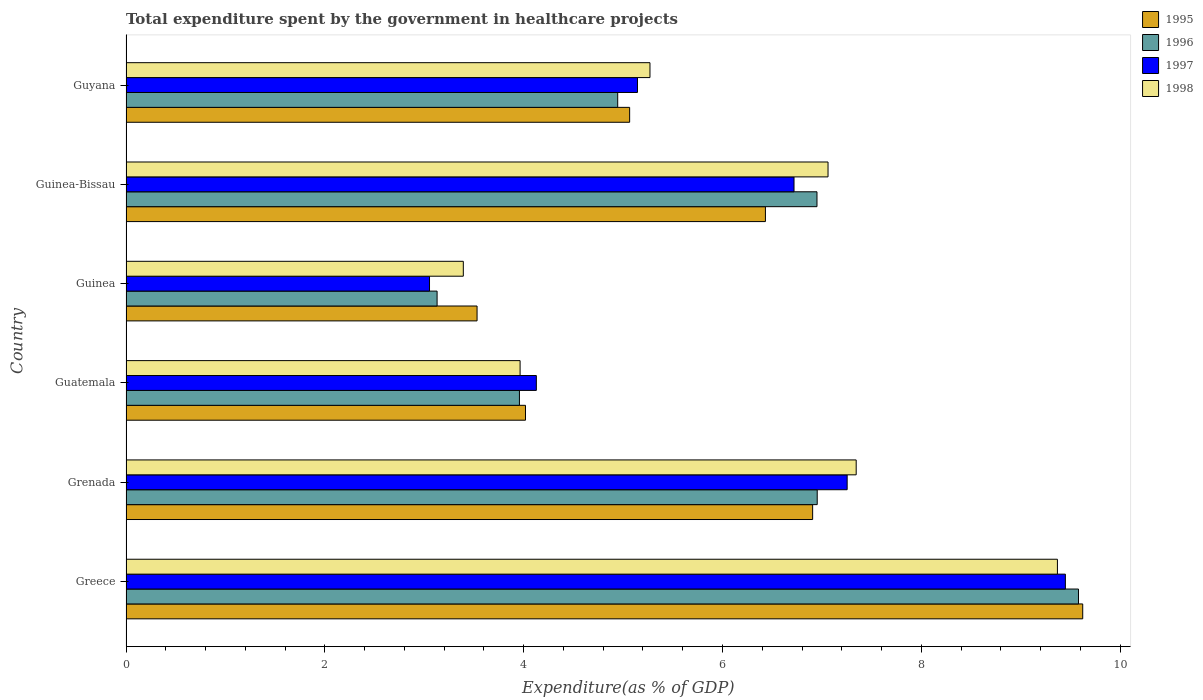How many different coloured bars are there?
Your response must be concise. 4. Are the number of bars on each tick of the Y-axis equal?
Your answer should be very brief. Yes. How many bars are there on the 6th tick from the top?
Give a very brief answer. 4. What is the label of the 3rd group of bars from the top?
Your answer should be very brief. Guinea. What is the total expenditure spent by the government in healthcare projects in 1998 in Grenada?
Your answer should be compact. 7.35. Across all countries, what is the maximum total expenditure spent by the government in healthcare projects in 1997?
Provide a succinct answer. 9.45. Across all countries, what is the minimum total expenditure spent by the government in healthcare projects in 1995?
Offer a terse response. 3.53. In which country was the total expenditure spent by the government in healthcare projects in 1995 maximum?
Provide a short and direct response. Greece. In which country was the total expenditure spent by the government in healthcare projects in 1996 minimum?
Keep it short and to the point. Guinea. What is the total total expenditure spent by the government in healthcare projects in 1998 in the graph?
Your response must be concise. 36.4. What is the difference between the total expenditure spent by the government in healthcare projects in 1995 in Guatemala and that in Guinea-Bissau?
Your answer should be compact. -2.41. What is the difference between the total expenditure spent by the government in healthcare projects in 1995 in Guyana and the total expenditure spent by the government in healthcare projects in 1998 in Grenada?
Provide a short and direct response. -2.28. What is the average total expenditure spent by the government in healthcare projects in 1998 per country?
Provide a succinct answer. 6.07. What is the difference between the total expenditure spent by the government in healthcare projects in 1998 and total expenditure spent by the government in healthcare projects in 1997 in Guatemala?
Keep it short and to the point. -0.16. What is the ratio of the total expenditure spent by the government in healthcare projects in 1996 in Grenada to that in Guinea?
Offer a very short reply. 2.22. Is the difference between the total expenditure spent by the government in healthcare projects in 1998 in Guinea-Bissau and Guyana greater than the difference between the total expenditure spent by the government in healthcare projects in 1997 in Guinea-Bissau and Guyana?
Provide a succinct answer. Yes. What is the difference between the highest and the second highest total expenditure spent by the government in healthcare projects in 1995?
Provide a short and direct response. 2.72. What is the difference between the highest and the lowest total expenditure spent by the government in healthcare projects in 1996?
Your answer should be very brief. 6.45. Is the sum of the total expenditure spent by the government in healthcare projects in 1997 in Greece and Guatemala greater than the maximum total expenditure spent by the government in healthcare projects in 1995 across all countries?
Provide a succinct answer. Yes. Is it the case that in every country, the sum of the total expenditure spent by the government in healthcare projects in 1996 and total expenditure spent by the government in healthcare projects in 1997 is greater than the sum of total expenditure spent by the government in healthcare projects in 1995 and total expenditure spent by the government in healthcare projects in 1998?
Keep it short and to the point. No. What does the 4th bar from the bottom in Guinea-Bissau represents?
Give a very brief answer. 1998. Is it the case that in every country, the sum of the total expenditure spent by the government in healthcare projects in 1996 and total expenditure spent by the government in healthcare projects in 1998 is greater than the total expenditure spent by the government in healthcare projects in 1997?
Make the answer very short. Yes. How many bars are there?
Your answer should be very brief. 24. What is the difference between two consecutive major ticks on the X-axis?
Make the answer very short. 2. Does the graph contain any zero values?
Keep it short and to the point. No. Does the graph contain grids?
Ensure brevity in your answer.  No. Where does the legend appear in the graph?
Offer a very short reply. Top right. What is the title of the graph?
Give a very brief answer. Total expenditure spent by the government in healthcare projects. What is the label or title of the X-axis?
Make the answer very short. Expenditure(as % of GDP). What is the label or title of the Y-axis?
Ensure brevity in your answer.  Country. What is the Expenditure(as % of GDP) in 1995 in Greece?
Your response must be concise. 9.62. What is the Expenditure(as % of GDP) in 1996 in Greece?
Your answer should be very brief. 9.58. What is the Expenditure(as % of GDP) in 1997 in Greece?
Give a very brief answer. 9.45. What is the Expenditure(as % of GDP) of 1998 in Greece?
Ensure brevity in your answer.  9.37. What is the Expenditure(as % of GDP) in 1995 in Grenada?
Your answer should be very brief. 6.91. What is the Expenditure(as % of GDP) in 1996 in Grenada?
Provide a succinct answer. 6.95. What is the Expenditure(as % of GDP) in 1997 in Grenada?
Your answer should be very brief. 7.25. What is the Expenditure(as % of GDP) of 1998 in Grenada?
Your answer should be very brief. 7.35. What is the Expenditure(as % of GDP) of 1995 in Guatemala?
Provide a succinct answer. 4.02. What is the Expenditure(as % of GDP) of 1996 in Guatemala?
Keep it short and to the point. 3.96. What is the Expenditure(as % of GDP) of 1997 in Guatemala?
Keep it short and to the point. 4.13. What is the Expenditure(as % of GDP) of 1998 in Guatemala?
Ensure brevity in your answer.  3.96. What is the Expenditure(as % of GDP) in 1995 in Guinea?
Your response must be concise. 3.53. What is the Expenditure(as % of GDP) of 1996 in Guinea?
Your response must be concise. 3.13. What is the Expenditure(as % of GDP) of 1997 in Guinea?
Keep it short and to the point. 3.05. What is the Expenditure(as % of GDP) in 1998 in Guinea?
Make the answer very short. 3.39. What is the Expenditure(as % of GDP) of 1995 in Guinea-Bissau?
Your answer should be compact. 6.43. What is the Expenditure(as % of GDP) of 1996 in Guinea-Bissau?
Ensure brevity in your answer.  6.95. What is the Expenditure(as % of GDP) in 1997 in Guinea-Bissau?
Provide a short and direct response. 6.72. What is the Expenditure(as % of GDP) in 1998 in Guinea-Bissau?
Offer a very short reply. 7.06. What is the Expenditure(as % of GDP) of 1995 in Guyana?
Your response must be concise. 5.07. What is the Expenditure(as % of GDP) in 1996 in Guyana?
Provide a short and direct response. 4.95. What is the Expenditure(as % of GDP) of 1997 in Guyana?
Offer a very short reply. 5.15. What is the Expenditure(as % of GDP) of 1998 in Guyana?
Make the answer very short. 5.27. Across all countries, what is the maximum Expenditure(as % of GDP) in 1995?
Give a very brief answer. 9.62. Across all countries, what is the maximum Expenditure(as % of GDP) in 1996?
Make the answer very short. 9.58. Across all countries, what is the maximum Expenditure(as % of GDP) of 1997?
Provide a short and direct response. 9.45. Across all countries, what is the maximum Expenditure(as % of GDP) of 1998?
Ensure brevity in your answer.  9.37. Across all countries, what is the minimum Expenditure(as % of GDP) of 1995?
Offer a terse response. 3.53. Across all countries, what is the minimum Expenditure(as % of GDP) of 1996?
Your response must be concise. 3.13. Across all countries, what is the minimum Expenditure(as % of GDP) in 1997?
Offer a very short reply. 3.05. Across all countries, what is the minimum Expenditure(as % of GDP) of 1998?
Your answer should be very brief. 3.39. What is the total Expenditure(as % of GDP) of 1995 in the graph?
Your answer should be compact. 35.58. What is the total Expenditure(as % of GDP) of 1996 in the graph?
Your response must be concise. 35.52. What is the total Expenditure(as % of GDP) of 1997 in the graph?
Keep it short and to the point. 35.75. What is the total Expenditure(as % of GDP) of 1998 in the graph?
Ensure brevity in your answer.  36.4. What is the difference between the Expenditure(as % of GDP) of 1995 in Greece and that in Grenada?
Your answer should be very brief. 2.72. What is the difference between the Expenditure(as % of GDP) in 1996 in Greece and that in Grenada?
Make the answer very short. 2.63. What is the difference between the Expenditure(as % of GDP) of 1997 in Greece and that in Grenada?
Ensure brevity in your answer.  2.2. What is the difference between the Expenditure(as % of GDP) in 1998 in Greece and that in Grenada?
Offer a very short reply. 2.02. What is the difference between the Expenditure(as % of GDP) in 1995 in Greece and that in Guatemala?
Your answer should be very brief. 5.61. What is the difference between the Expenditure(as % of GDP) in 1996 in Greece and that in Guatemala?
Your answer should be compact. 5.62. What is the difference between the Expenditure(as % of GDP) of 1997 in Greece and that in Guatemala?
Make the answer very short. 5.32. What is the difference between the Expenditure(as % of GDP) in 1998 in Greece and that in Guatemala?
Your answer should be very brief. 5.41. What is the difference between the Expenditure(as % of GDP) of 1995 in Greece and that in Guinea?
Provide a succinct answer. 6.09. What is the difference between the Expenditure(as % of GDP) in 1996 in Greece and that in Guinea?
Offer a terse response. 6.45. What is the difference between the Expenditure(as % of GDP) in 1997 in Greece and that in Guinea?
Provide a succinct answer. 6.4. What is the difference between the Expenditure(as % of GDP) in 1998 in Greece and that in Guinea?
Give a very brief answer. 5.98. What is the difference between the Expenditure(as % of GDP) of 1995 in Greece and that in Guinea-Bissau?
Provide a succinct answer. 3.19. What is the difference between the Expenditure(as % of GDP) in 1996 in Greece and that in Guinea-Bissau?
Your answer should be very brief. 2.63. What is the difference between the Expenditure(as % of GDP) in 1997 in Greece and that in Guinea-Bissau?
Provide a short and direct response. 2.73. What is the difference between the Expenditure(as % of GDP) of 1998 in Greece and that in Guinea-Bissau?
Your answer should be very brief. 2.31. What is the difference between the Expenditure(as % of GDP) in 1995 in Greece and that in Guyana?
Give a very brief answer. 4.56. What is the difference between the Expenditure(as % of GDP) of 1996 in Greece and that in Guyana?
Give a very brief answer. 4.64. What is the difference between the Expenditure(as % of GDP) of 1997 in Greece and that in Guyana?
Ensure brevity in your answer.  4.3. What is the difference between the Expenditure(as % of GDP) in 1998 in Greece and that in Guyana?
Provide a short and direct response. 4.1. What is the difference between the Expenditure(as % of GDP) of 1995 in Grenada and that in Guatemala?
Give a very brief answer. 2.89. What is the difference between the Expenditure(as % of GDP) of 1996 in Grenada and that in Guatemala?
Your answer should be very brief. 3. What is the difference between the Expenditure(as % of GDP) in 1997 in Grenada and that in Guatemala?
Make the answer very short. 3.13. What is the difference between the Expenditure(as % of GDP) of 1998 in Grenada and that in Guatemala?
Provide a succinct answer. 3.38. What is the difference between the Expenditure(as % of GDP) of 1995 in Grenada and that in Guinea?
Your answer should be very brief. 3.38. What is the difference between the Expenditure(as % of GDP) of 1996 in Grenada and that in Guinea?
Offer a very short reply. 3.82. What is the difference between the Expenditure(as % of GDP) in 1997 in Grenada and that in Guinea?
Your response must be concise. 4.2. What is the difference between the Expenditure(as % of GDP) in 1998 in Grenada and that in Guinea?
Provide a short and direct response. 3.95. What is the difference between the Expenditure(as % of GDP) in 1995 in Grenada and that in Guinea-Bissau?
Your response must be concise. 0.47. What is the difference between the Expenditure(as % of GDP) in 1996 in Grenada and that in Guinea-Bissau?
Offer a very short reply. 0. What is the difference between the Expenditure(as % of GDP) of 1997 in Grenada and that in Guinea-Bissau?
Your response must be concise. 0.53. What is the difference between the Expenditure(as % of GDP) in 1998 in Grenada and that in Guinea-Bissau?
Keep it short and to the point. 0.28. What is the difference between the Expenditure(as % of GDP) in 1995 in Grenada and that in Guyana?
Offer a terse response. 1.84. What is the difference between the Expenditure(as % of GDP) in 1996 in Grenada and that in Guyana?
Provide a succinct answer. 2.01. What is the difference between the Expenditure(as % of GDP) of 1997 in Grenada and that in Guyana?
Provide a short and direct response. 2.11. What is the difference between the Expenditure(as % of GDP) of 1998 in Grenada and that in Guyana?
Your answer should be compact. 2.07. What is the difference between the Expenditure(as % of GDP) in 1995 in Guatemala and that in Guinea?
Provide a succinct answer. 0.49. What is the difference between the Expenditure(as % of GDP) in 1996 in Guatemala and that in Guinea?
Offer a terse response. 0.83. What is the difference between the Expenditure(as % of GDP) of 1997 in Guatemala and that in Guinea?
Provide a short and direct response. 1.07. What is the difference between the Expenditure(as % of GDP) in 1998 in Guatemala and that in Guinea?
Provide a short and direct response. 0.57. What is the difference between the Expenditure(as % of GDP) of 1995 in Guatemala and that in Guinea-Bissau?
Your response must be concise. -2.41. What is the difference between the Expenditure(as % of GDP) of 1996 in Guatemala and that in Guinea-Bissau?
Provide a succinct answer. -2.99. What is the difference between the Expenditure(as % of GDP) of 1997 in Guatemala and that in Guinea-Bissau?
Make the answer very short. -2.59. What is the difference between the Expenditure(as % of GDP) in 1998 in Guatemala and that in Guinea-Bissau?
Provide a short and direct response. -3.1. What is the difference between the Expenditure(as % of GDP) in 1995 in Guatemala and that in Guyana?
Your answer should be very brief. -1.05. What is the difference between the Expenditure(as % of GDP) of 1996 in Guatemala and that in Guyana?
Offer a terse response. -0.99. What is the difference between the Expenditure(as % of GDP) in 1997 in Guatemala and that in Guyana?
Give a very brief answer. -1.02. What is the difference between the Expenditure(as % of GDP) of 1998 in Guatemala and that in Guyana?
Provide a short and direct response. -1.31. What is the difference between the Expenditure(as % of GDP) in 1995 in Guinea and that in Guinea-Bissau?
Your answer should be very brief. -2.9. What is the difference between the Expenditure(as % of GDP) of 1996 in Guinea and that in Guinea-Bissau?
Keep it short and to the point. -3.82. What is the difference between the Expenditure(as % of GDP) of 1997 in Guinea and that in Guinea-Bissau?
Your answer should be compact. -3.67. What is the difference between the Expenditure(as % of GDP) in 1998 in Guinea and that in Guinea-Bissau?
Keep it short and to the point. -3.67. What is the difference between the Expenditure(as % of GDP) in 1995 in Guinea and that in Guyana?
Provide a succinct answer. -1.53. What is the difference between the Expenditure(as % of GDP) in 1996 in Guinea and that in Guyana?
Your response must be concise. -1.82. What is the difference between the Expenditure(as % of GDP) of 1997 in Guinea and that in Guyana?
Offer a terse response. -2.09. What is the difference between the Expenditure(as % of GDP) of 1998 in Guinea and that in Guyana?
Make the answer very short. -1.88. What is the difference between the Expenditure(as % of GDP) of 1995 in Guinea-Bissau and that in Guyana?
Provide a short and direct response. 1.37. What is the difference between the Expenditure(as % of GDP) of 1996 in Guinea-Bissau and that in Guyana?
Offer a very short reply. 2. What is the difference between the Expenditure(as % of GDP) in 1997 in Guinea-Bissau and that in Guyana?
Give a very brief answer. 1.57. What is the difference between the Expenditure(as % of GDP) of 1998 in Guinea-Bissau and that in Guyana?
Your answer should be compact. 1.79. What is the difference between the Expenditure(as % of GDP) in 1995 in Greece and the Expenditure(as % of GDP) in 1996 in Grenada?
Your response must be concise. 2.67. What is the difference between the Expenditure(as % of GDP) of 1995 in Greece and the Expenditure(as % of GDP) of 1997 in Grenada?
Make the answer very short. 2.37. What is the difference between the Expenditure(as % of GDP) of 1995 in Greece and the Expenditure(as % of GDP) of 1998 in Grenada?
Your answer should be very brief. 2.28. What is the difference between the Expenditure(as % of GDP) of 1996 in Greece and the Expenditure(as % of GDP) of 1997 in Grenada?
Ensure brevity in your answer.  2.33. What is the difference between the Expenditure(as % of GDP) in 1996 in Greece and the Expenditure(as % of GDP) in 1998 in Grenada?
Your answer should be compact. 2.24. What is the difference between the Expenditure(as % of GDP) in 1997 in Greece and the Expenditure(as % of GDP) in 1998 in Grenada?
Your answer should be very brief. 2.1. What is the difference between the Expenditure(as % of GDP) in 1995 in Greece and the Expenditure(as % of GDP) in 1996 in Guatemala?
Ensure brevity in your answer.  5.67. What is the difference between the Expenditure(as % of GDP) in 1995 in Greece and the Expenditure(as % of GDP) in 1997 in Guatemala?
Your response must be concise. 5.5. What is the difference between the Expenditure(as % of GDP) in 1995 in Greece and the Expenditure(as % of GDP) in 1998 in Guatemala?
Make the answer very short. 5.66. What is the difference between the Expenditure(as % of GDP) in 1996 in Greece and the Expenditure(as % of GDP) in 1997 in Guatemala?
Make the answer very short. 5.45. What is the difference between the Expenditure(as % of GDP) in 1996 in Greece and the Expenditure(as % of GDP) in 1998 in Guatemala?
Ensure brevity in your answer.  5.62. What is the difference between the Expenditure(as % of GDP) of 1997 in Greece and the Expenditure(as % of GDP) of 1998 in Guatemala?
Offer a terse response. 5.49. What is the difference between the Expenditure(as % of GDP) in 1995 in Greece and the Expenditure(as % of GDP) in 1996 in Guinea?
Your response must be concise. 6.49. What is the difference between the Expenditure(as % of GDP) of 1995 in Greece and the Expenditure(as % of GDP) of 1997 in Guinea?
Ensure brevity in your answer.  6.57. What is the difference between the Expenditure(as % of GDP) of 1995 in Greece and the Expenditure(as % of GDP) of 1998 in Guinea?
Your answer should be very brief. 6.23. What is the difference between the Expenditure(as % of GDP) of 1996 in Greece and the Expenditure(as % of GDP) of 1997 in Guinea?
Ensure brevity in your answer.  6.53. What is the difference between the Expenditure(as % of GDP) in 1996 in Greece and the Expenditure(as % of GDP) in 1998 in Guinea?
Provide a succinct answer. 6.19. What is the difference between the Expenditure(as % of GDP) in 1997 in Greece and the Expenditure(as % of GDP) in 1998 in Guinea?
Offer a very short reply. 6.06. What is the difference between the Expenditure(as % of GDP) in 1995 in Greece and the Expenditure(as % of GDP) in 1996 in Guinea-Bissau?
Give a very brief answer. 2.67. What is the difference between the Expenditure(as % of GDP) in 1995 in Greece and the Expenditure(as % of GDP) in 1997 in Guinea-Bissau?
Your answer should be compact. 2.9. What is the difference between the Expenditure(as % of GDP) in 1995 in Greece and the Expenditure(as % of GDP) in 1998 in Guinea-Bissau?
Your response must be concise. 2.56. What is the difference between the Expenditure(as % of GDP) in 1996 in Greece and the Expenditure(as % of GDP) in 1997 in Guinea-Bissau?
Keep it short and to the point. 2.86. What is the difference between the Expenditure(as % of GDP) in 1996 in Greece and the Expenditure(as % of GDP) in 1998 in Guinea-Bissau?
Your answer should be very brief. 2.52. What is the difference between the Expenditure(as % of GDP) of 1997 in Greece and the Expenditure(as % of GDP) of 1998 in Guinea-Bissau?
Make the answer very short. 2.39. What is the difference between the Expenditure(as % of GDP) in 1995 in Greece and the Expenditure(as % of GDP) in 1996 in Guyana?
Offer a very short reply. 4.68. What is the difference between the Expenditure(as % of GDP) of 1995 in Greece and the Expenditure(as % of GDP) of 1997 in Guyana?
Provide a succinct answer. 4.48. What is the difference between the Expenditure(as % of GDP) of 1995 in Greece and the Expenditure(as % of GDP) of 1998 in Guyana?
Provide a succinct answer. 4.35. What is the difference between the Expenditure(as % of GDP) in 1996 in Greece and the Expenditure(as % of GDP) in 1997 in Guyana?
Your response must be concise. 4.44. What is the difference between the Expenditure(as % of GDP) of 1996 in Greece and the Expenditure(as % of GDP) of 1998 in Guyana?
Provide a succinct answer. 4.31. What is the difference between the Expenditure(as % of GDP) of 1997 in Greece and the Expenditure(as % of GDP) of 1998 in Guyana?
Your response must be concise. 4.18. What is the difference between the Expenditure(as % of GDP) in 1995 in Grenada and the Expenditure(as % of GDP) in 1996 in Guatemala?
Provide a succinct answer. 2.95. What is the difference between the Expenditure(as % of GDP) of 1995 in Grenada and the Expenditure(as % of GDP) of 1997 in Guatemala?
Ensure brevity in your answer.  2.78. What is the difference between the Expenditure(as % of GDP) in 1995 in Grenada and the Expenditure(as % of GDP) in 1998 in Guatemala?
Offer a terse response. 2.94. What is the difference between the Expenditure(as % of GDP) of 1996 in Grenada and the Expenditure(as % of GDP) of 1997 in Guatemala?
Your answer should be compact. 2.83. What is the difference between the Expenditure(as % of GDP) in 1996 in Grenada and the Expenditure(as % of GDP) in 1998 in Guatemala?
Offer a very short reply. 2.99. What is the difference between the Expenditure(as % of GDP) in 1997 in Grenada and the Expenditure(as % of GDP) in 1998 in Guatemala?
Your answer should be compact. 3.29. What is the difference between the Expenditure(as % of GDP) in 1995 in Grenada and the Expenditure(as % of GDP) in 1996 in Guinea?
Offer a very short reply. 3.78. What is the difference between the Expenditure(as % of GDP) in 1995 in Grenada and the Expenditure(as % of GDP) in 1997 in Guinea?
Offer a very short reply. 3.85. What is the difference between the Expenditure(as % of GDP) of 1995 in Grenada and the Expenditure(as % of GDP) of 1998 in Guinea?
Your response must be concise. 3.51. What is the difference between the Expenditure(as % of GDP) of 1996 in Grenada and the Expenditure(as % of GDP) of 1997 in Guinea?
Ensure brevity in your answer.  3.9. What is the difference between the Expenditure(as % of GDP) in 1996 in Grenada and the Expenditure(as % of GDP) in 1998 in Guinea?
Keep it short and to the point. 3.56. What is the difference between the Expenditure(as % of GDP) in 1997 in Grenada and the Expenditure(as % of GDP) in 1998 in Guinea?
Make the answer very short. 3.86. What is the difference between the Expenditure(as % of GDP) of 1995 in Grenada and the Expenditure(as % of GDP) of 1996 in Guinea-Bissau?
Your answer should be very brief. -0.04. What is the difference between the Expenditure(as % of GDP) in 1995 in Grenada and the Expenditure(as % of GDP) in 1997 in Guinea-Bissau?
Make the answer very short. 0.19. What is the difference between the Expenditure(as % of GDP) of 1995 in Grenada and the Expenditure(as % of GDP) of 1998 in Guinea-Bissau?
Provide a short and direct response. -0.15. What is the difference between the Expenditure(as % of GDP) in 1996 in Grenada and the Expenditure(as % of GDP) in 1997 in Guinea-Bissau?
Ensure brevity in your answer.  0.23. What is the difference between the Expenditure(as % of GDP) in 1996 in Grenada and the Expenditure(as % of GDP) in 1998 in Guinea-Bissau?
Keep it short and to the point. -0.11. What is the difference between the Expenditure(as % of GDP) of 1997 in Grenada and the Expenditure(as % of GDP) of 1998 in Guinea-Bissau?
Ensure brevity in your answer.  0.19. What is the difference between the Expenditure(as % of GDP) of 1995 in Grenada and the Expenditure(as % of GDP) of 1996 in Guyana?
Provide a succinct answer. 1.96. What is the difference between the Expenditure(as % of GDP) in 1995 in Grenada and the Expenditure(as % of GDP) in 1997 in Guyana?
Ensure brevity in your answer.  1.76. What is the difference between the Expenditure(as % of GDP) in 1995 in Grenada and the Expenditure(as % of GDP) in 1998 in Guyana?
Your response must be concise. 1.64. What is the difference between the Expenditure(as % of GDP) in 1996 in Grenada and the Expenditure(as % of GDP) in 1997 in Guyana?
Your response must be concise. 1.81. What is the difference between the Expenditure(as % of GDP) in 1996 in Grenada and the Expenditure(as % of GDP) in 1998 in Guyana?
Your answer should be compact. 1.68. What is the difference between the Expenditure(as % of GDP) in 1997 in Grenada and the Expenditure(as % of GDP) in 1998 in Guyana?
Offer a very short reply. 1.98. What is the difference between the Expenditure(as % of GDP) of 1995 in Guatemala and the Expenditure(as % of GDP) of 1996 in Guinea?
Make the answer very short. 0.89. What is the difference between the Expenditure(as % of GDP) of 1995 in Guatemala and the Expenditure(as % of GDP) of 1997 in Guinea?
Offer a terse response. 0.97. What is the difference between the Expenditure(as % of GDP) in 1995 in Guatemala and the Expenditure(as % of GDP) in 1998 in Guinea?
Ensure brevity in your answer.  0.63. What is the difference between the Expenditure(as % of GDP) in 1996 in Guatemala and the Expenditure(as % of GDP) in 1997 in Guinea?
Offer a terse response. 0.9. What is the difference between the Expenditure(as % of GDP) of 1996 in Guatemala and the Expenditure(as % of GDP) of 1998 in Guinea?
Keep it short and to the point. 0.56. What is the difference between the Expenditure(as % of GDP) in 1997 in Guatemala and the Expenditure(as % of GDP) in 1998 in Guinea?
Offer a very short reply. 0.73. What is the difference between the Expenditure(as % of GDP) of 1995 in Guatemala and the Expenditure(as % of GDP) of 1996 in Guinea-Bissau?
Offer a very short reply. -2.93. What is the difference between the Expenditure(as % of GDP) of 1995 in Guatemala and the Expenditure(as % of GDP) of 1997 in Guinea-Bissau?
Give a very brief answer. -2.7. What is the difference between the Expenditure(as % of GDP) of 1995 in Guatemala and the Expenditure(as % of GDP) of 1998 in Guinea-Bissau?
Offer a terse response. -3.04. What is the difference between the Expenditure(as % of GDP) in 1996 in Guatemala and the Expenditure(as % of GDP) in 1997 in Guinea-Bissau?
Your answer should be compact. -2.76. What is the difference between the Expenditure(as % of GDP) of 1996 in Guatemala and the Expenditure(as % of GDP) of 1998 in Guinea-Bissau?
Offer a terse response. -3.1. What is the difference between the Expenditure(as % of GDP) in 1997 in Guatemala and the Expenditure(as % of GDP) in 1998 in Guinea-Bissau?
Your answer should be compact. -2.93. What is the difference between the Expenditure(as % of GDP) in 1995 in Guatemala and the Expenditure(as % of GDP) in 1996 in Guyana?
Give a very brief answer. -0.93. What is the difference between the Expenditure(as % of GDP) of 1995 in Guatemala and the Expenditure(as % of GDP) of 1997 in Guyana?
Provide a short and direct response. -1.13. What is the difference between the Expenditure(as % of GDP) in 1995 in Guatemala and the Expenditure(as % of GDP) in 1998 in Guyana?
Your answer should be compact. -1.25. What is the difference between the Expenditure(as % of GDP) in 1996 in Guatemala and the Expenditure(as % of GDP) in 1997 in Guyana?
Ensure brevity in your answer.  -1.19. What is the difference between the Expenditure(as % of GDP) in 1996 in Guatemala and the Expenditure(as % of GDP) in 1998 in Guyana?
Give a very brief answer. -1.31. What is the difference between the Expenditure(as % of GDP) of 1997 in Guatemala and the Expenditure(as % of GDP) of 1998 in Guyana?
Your answer should be very brief. -1.14. What is the difference between the Expenditure(as % of GDP) in 1995 in Guinea and the Expenditure(as % of GDP) in 1996 in Guinea-Bissau?
Give a very brief answer. -3.42. What is the difference between the Expenditure(as % of GDP) of 1995 in Guinea and the Expenditure(as % of GDP) of 1997 in Guinea-Bissau?
Give a very brief answer. -3.19. What is the difference between the Expenditure(as % of GDP) in 1995 in Guinea and the Expenditure(as % of GDP) in 1998 in Guinea-Bissau?
Make the answer very short. -3.53. What is the difference between the Expenditure(as % of GDP) of 1996 in Guinea and the Expenditure(as % of GDP) of 1997 in Guinea-Bissau?
Offer a very short reply. -3.59. What is the difference between the Expenditure(as % of GDP) in 1996 in Guinea and the Expenditure(as % of GDP) in 1998 in Guinea-Bissau?
Provide a short and direct response. -3.93. What is the difference between the Expenditure(as % of GDP) of 1997 in Guinea and the Expenditure(as % of GDP) of 1998 in Guinea-Bissau?
Offer a terse response. -4.01. What is the difference between the Expenditure(as % of GDP) of 1995 in Guinea and the Expenditure(as % of GDP) of 1996 in Guyana?
Keep it short and to the point. -1.41. What is the difference between the Expenditure(as % of GDP) of 1995 in Guinea and the Expenditure(as % of GDP) of 1997 in Guyana?
Ensure brevity in your answer.  -1.61. What is the difference between the Expenditure(as % of GDP) in 1995 in Guinea and the Expenditure(as % of GDP) in 1998 in Guyana?
Offer a very short reply. -1.74. What is the difference between the Expenditure(as % of GDP) in 1996 in Guinea and the Expenditure(as % of GDP) in 1997 in Guyana?
Offer a terse response. -2.02. What is the difference between the Expenditure(as % of GDP) of 1996 in Guinea and the Expenditure(as % of GDP) of 1998 in Guyana?
Your response must be concise. -2.14. What is the difference between the Expenditure(as % of GDP) of 1997 in Guinea and the Expenditure(as % of GDP) of 1998 in Guyana?
Provide a succinct answer. -2.22. What is the difference between the Expenditure(as % of GDP) in 1995 in Guinea-Bissau and the Expenditure(as % of GDP) in 1996 in Guyana?
Give a very brief answer. 1.49. What is the difference between the Expenditure(as % of GDP) in 1995 in Guinea-Bissau and the Expenditure(as % of GDP) in 1997 in Guyana?
Keep it short and to the point. 1.29. What is the difference between the Expenditure(as % of GDP) of 1995 in Guinea-Bissau and the Expenditure(as % of GDP) of 1998 in Guyana?
Your answer should be compact. 1.16. What is the difference between the Expenditure(as % of GDP) of 1996 in Guinea-Bissau and the Expenditure(as % of GDP) of 1997 in Guyana?
Your response must be concise. 1.81. What is the difference between the Expenditure(as % of GDP) of 1996 in Guinea-Bissau and the Expenditure(as % of GDP) of 1998 in Guyana?
Give a very brief answer. 1.68. What is the difference between the Expenditure(as % of GDP) of 1997 in Guinea-Bissau and the Expenditure(as % of GDP) of 1998 in Guyana?
Make the answer very short. 1.45. What is the average Expenditure(as % of GDP) of 1995 per country?
Your response must be concise. 5.93. What is the average Expenditure(as % of GDP) in 1996 per country?
Offer a terse response. 5.92. What is the average Expenditure(as % of GDP) in 1997 per country?
Give a very brief answer. 5.96. What is the average Expenditure(as % of GDP) of 1998 per country?
Make the answer very short. 6.07. What is the difference between the Expenditure(as % of GDP) of 1995 and Expenditure(as % of GDP) of 1996 in Greece?
Your answer should be very brief. 0.04. What is the difference between the Expenditure(as % of GDP) in 1995 and Expenditure(as % of GDP) in 1997 in Greece?
Give a very brief answer. 0.17. What is the difference between the Expenditure(as % of GDP) of 1995 and Expenditure(as % of GDP) of 1998 in Greece?
Ensure brevity in your answer.  0.25. What is the difference between the Expenditure(as % of GDP) of 1996 and Expenditure(as % of GDP) of 1997 in Greece?
Offer a very short reply. 0.13. What is the difference between the Expenditure(as % of GDP) of 1996 and Expenditure(as % of GDP) of 1998 in Greece?
Make the answer very short. 0.21. What is the difference between the Expenditure(as % of GDP) in 1997 and Expenditure(as % of GDP) in 1998 in Greece?
Your answer should be compact. 0.08. What is the difference between the Expenditure(as % of GDP) of 1995 and Expenditure(as % of GDP) of 1996 in Grenada?
Your response must be concise. -0.05. What is the difference between the Expenditure(as % of GDP) in 1995 and Expenditure(as % of GDP) in 1997 in Grenada?
Your answer should be compact. -0.35. What is the difference between the Expenditure(as % of GDP) of 1995 and Expenditure(as % of GDP) of 1998 in Grenada?
Offer a terse response. -0.44. What is the difference between the Expenditure(as % of GDP) of 1996 and Expenditure(as % of GDP) of 1997 in Grenada?
Provide a succinct answer. -0.3. What is the difference between the Expenditure(as % of GDP) of 1996 and Expenditure(as % of GDP) of 1998 in Grenada?
Provide a short and direct response. -0.39. What is the difference between the Expenditure(as % of GDP) in 1997 and Expenditure(as % of GDP) in 1998 in Grenada?
Your answer should be compact. -0.09. What is the difference between the Expenditure(as % of GDP) in 1995 and Expenditure(as % of GDP) in 1996 in Guatemala?
Keep it short and to the point. 0.06. What is the difference between the Expenditure(as % of GDP) of 1995 and Expenditure(as % of GDP) of 1997 in Guatemala?
Your answer should be compact. -0.11. What is the difference between the Expenditure(as % of GDP) in 1995 and Expenditure(as % of GDP) in 1998 in Guatemala?
Give a very brief answer. 0.05. What is the difference between the Expenditure(as % of GDP) in 1996 and Expenditure(as % of GDP) in 1997 in Guatemala?
Offer a very short reply. -0.17. What is the difference between the Expenditure(as % of GDP) in 1996 and Expenditure(as % of GDP) in 1998 in Guatemala?
Ensure brevity in your answer.  -0.01. What is the difference between the Expenditure(as % of GDP) in 1997 and Expenditure(as % of GDP) in 1998 in Guatemala?
Make the answer very short. 0.16. What is the difference between the Expenditure(as % of GDP) in 1995 and Expenditure(as % of GDP) in 1996 in Guinea?
Provide a short and direct response. 0.4. What is the difference between the Expenditure(as % of GDP) in 1995 and Expenditure(as % of GDP) in 1997 in Guinea?
Give a very brief answer. 0.48. What is the difference between the Expenditure(as % of GDP) of 1995 and Expenditure(as % of GDP) of 1998 in Guinea?
Your answer should be compact. 0.14. What is the difference between the Expenditure(as % of GDP) of 1996 and Expenditure(as % of GDP) of 1997 in Guinea?
Offer a terse response. 0.08. What is the difference between the Expenditure(as % of GDP) of 1996 and Expenditure(as % of GDP) of 1998 in Guinea?
Provide a short and direct response. -0.26. What is the difference between the Expenditure(as % of GDP) in 1997 and Expenditure(as % of GDP) in 1998 in Guinea?
Offer a terse response. -0.34. What is the difference between the Expenditure(as % of GDP) of 1995 and Expenditure(as % of GDP) of 1996 in Guinea-Bissau?
Give a very brief answer. -0.52. What is the difference between the Expenditure(as % of GDP) of 1995 and Expenditure(as % of GDP) of 1997 in Guinea-Bissau?
Offer a very short reply. -0.29. What is the difference between the Expenditure(as % of GDP) of 1995 and Expenditure(as % of GDP) of 1998 in Guinea-Bissau?
Your response must be concise. -0.63. What is the difference between the Expenditure(as % of GDP) in 1996 and Expenditure(as % of GDP) in 1997 in Guinea-Bissau?
Your response must be concise. 0.23. What is the difference between the Expenditure(as % of GDP) in 1996 and Expenditure(as % of GDP) in 1998 in Guinea-Bissau?
Your answer should be very brief. -0.11. What is the difference between the Expenditure(as % of GDP) of 1997 and Expenditure(as % of GDP) of 1998 in Guinea-Bissau?
Keep it short and to the point. -0.34. What is the difference between the Expenditure(as % of GDP) of 1995 and Expenditure(as % of GDP) of 1996 in Guyana?
Provide a succinct answer. 0.12. What is the difference between the Expenditure(as % of GDP) of 1995 and Expenditure(as % of GDP) of 1997 in Guyana?
Ensure brevity in your answer.  -0.08. What is the difference between the Expenditure(as % of GDP) in 1995 and Expenditure(as % of GDP) in 1998 in Guyana?
Keep it short and to the point. -0.2. What is the difference between the Expenditure(as % of GDP) of 1996 and Expenditure(as % of GDP) of 1997 in Guyana?
Offer a terse response. -0.2. What is the difference between the Expenditure(as % of GDP) of 1996 and Expenditure(as % of GDP) of 1998 in Guyana?
Keep it short and to the point. -0.32. What is the difference between the Expenditure(as % of GDP) in 1997 and Expenditure(as % of GDP) in 1998 in Guyana?
Your answer should be compact. -0.13. What is the ratio of the Expenditure(as % of GDP) in 1995 in Greece to that in Grenada?
Provide a succinct answer. 1.39. What is the ratio of the Expenditure(as % of GDP) of 1996 in Greece to that in Grenada?
Offer a terse response. 1.38. What is the ratio of the Expenditure(as % of GDP) in 1997 in Greece to that in Grenada?
Give a very brief answer. 1.3. What is the ratio of the Expenditure(as % of GDP) of 1998 in Greece to that in Grenada?
Provide a short and direct response. 1.28. What is the ratio of the Expenditure(as % of GDP) of 1995 in Greece to that in Guatemala?
Give a very brief answer. 2.39. What is the ratio of the Expenditure(as % of GDP) in 1996 in Greece to that in Guatemala?
Your response must be concise. 2.42. What is the ratio of the Expenditure(as % of GDP) of 1997 in Greece to that in Guatemala?
Provide a short and direct response. 2.29. What is the ratio of the Expenditure(as % of GDP) in 1998 in Greece to that in Guatemala?
Keep it short and to the point. 2.36. What is the ratio of the Expenditure(as % of GDP) of 1995 in Greece to that in Guinea?
Your response must be concise. 2.73. What is the ratio of the Expenditure(as % of GDP) of 1996 in Greece to that in Guinea?
Your answer should be very brief. 3.06. What is the ratio of the Expenditure(as % of GDP) of 1997 in Greece to that in Guinea?
Provide a short and direct response. 3.1. What is the ratio of the Expenditure(as % of GDP) in 1998 in Greece to that in Guinea?
Make the answer very short. 2.76. What is the ratio of the Expenditure(as % of GDP) of 1995 in Greece to that in Guinea-Bissau?
Your answer should be compact. 1.5. What is the ratio of the Expenditure(as % of GDP) in 1996 in Greece to that in Guinea-Bissau?
Provide a succinct answer. 1.38. What is the ratio of the Expenditure(as % of GDP) of 1997 in Greece to that in Guinea-Bissau?
Give a very brief answer. 1.41. What is the ratio of the Expenditure(as % of GDP) in 1998 in Greece to that in Guinea-Bissau?
Give a very brief answer. 1.33. What is the ratio of the Expenditure(as % of GDP) in 1995 in Greece to that in Guyana?
Offer a terse response. 1.9. What is the ratio of the Expenditure(as % of GDP) of 1996 in Greece to that in Guyana?
Provide a short and direct response. 1.94. What is the ratio of the Expenditure(as % of GDP) of 1997 in Greece to that in Guyana?
Your answer should be compact. 1.84. What is the ratio of the Expenditure(as % of GDP) in 1998 in Greece to that in Guyana?
Your answer should be compact. 1.78. What is the ratio of the Expenditure(as % of GDP) of 1995 in Grenada to that in Guatemala?
Offer a very short reply. 1.72. What is the ratio of the Expenditure(as % of GDP) in 1996 in Grenada to that in Guatemala?
Offer a terse response. 1.76. What is the ratio of the Expenditure(as % of GDP) in 1997 in Grenada to that in Guatemala?
Give a very brief answer. 1.76. What is the ratio of the Expenditure(as % of GDP) in 1998 in Grenada to that in Guatemala?
Offer a very short reply. 1.85. What is the ratio of the Expenditure(as % of GDP) in 1995 in Grenada to that in Guinea?
Give a very brief answer. 1.96. What is the ratio of the Expenditure(as % of GDP) in 1996 in Grenada to that in Guinea?
Provide a succinct answer. 2.22. What is the ratio of the Expenditure(as % of GDP) of 1997 in Grenada to that in Guinea?
Offer a very short reply. 2.38. What is the ratio of the Expenditure(as % of GDP) of 1998 in Grenada to that in Guinea?
Your answer should be very brief. 2.16. What is the ratio of the Expenditure(as % of GDP) in 1995 in Grenada to that in Guinea-Bissau?
Make the answer very short. 1.07. What is the ratio of the Expenditure(as % of GDP) in 1996 in Grenada to that in Guinea-Bissau?
Make the answer very short. 1. What is the ratio of the Expenditure(as % of GDP) in 1997 in Grenada to that in Guinea-Bissau?
Your response must be concise. 1.08. What is the ratio of the Expenditure(as % of GDP) in 1998 in Grenada to that in Guinea-Bissau?
Provide a succinct answer. 1.04. What is the ratio of the Expenditure(as % of GDP) in 1995 in Grenada to that in Guyana?
Provide a short and direct response. 1.36. What is the ratio of the Expenditure(as % of GDP) in 1996 in Grenada to that in Guyana?
Keep it short and to the point. 1.41. What is the ratio of the Expenditure(as % of GDP) in 1997 in Grenada to that in Guyana?
Give a very brief answer. 1.41. What is the ratio of the Expenditure(as % of GDP) of 1998 in Grenada to that in Guyana?
Offer a very short reply. 1.39. What is the ratio of the Expenditure(as % of GDP) in 1995 in Guatemala to that in Guinea?
Make the answer very short. 1.14. What is the ratio of the Expenditure(as % of GDP) in 1996 in Guatemala to that in Guinea?
Ensure brevity in your answer.  1.26. What is the ratio of the Expenditure(as % of GDP) of 1997 in Guatemala to that in Guinea?
Your answer should be compact. 1.35. What is the ratio of the Expenditure(as % of GDP) in 1998 in Guatemala to that in Guinea?
Your response must be concise. 1.17. What is the ratio of the Expenditure(as % of GDP) in 1995 in Guatemala to that in Guinea-Bissau?
Your answer should be compact. 0.62. What is the ratio of the Expenditure(as % of GDP) of 1996 in Guatemala to that in Guinea-Bissau?
Your response must be concise. 0.57. What is the ratio of the Expenditure(as % of GDP) in 1997 in Guatemala to that in Guinea-Bissau?
Keep it short and to the point. 0.61. What is the ratio of the Expenditure(as % of GDP) in 1998 in Guatemala to that in Guinea-Bissau?
Keep it short and to the point. 0.56. What is the ratio of the Expenditure(as % of GDP) in 1995 in Guatemala to that in Guyana?
Offer a very short reply. 0.79. What is the ratio of the Expenditure(as % of GDP) of 1996 in Guatemala to that in Guyana?
Keep it short and to the point. 0.8. What is the ratio of the Expenditure(as % of GDP) in 1997 in Guatemala to that in Guyana?
Give a very brief answer. 0.8. What is the ratio of the Expenditure(as % of GDP) in 1998 in Guatemala to that in Guyana?
Keep it short and to the point. 0.75. What is the ratio of the Expenditure(as % of GDP) of 1995 in Guinea to that in Guinea-Bissau?
Make the answer very short. 0.55. What is the ratio of the Expenditure(as % of GDP) in 1996 in Guinea to that in Guinea-Bissau?
Provide a succinct answer. 0.45. What is the ratio of the Expenditure(as % of GDP) of 1997 in Guinea to that in Guinea-Bissau?
Provide a short and direct response. 0.45. What is the ratio of the Expenditure(as % of GDP) of 1998 in Guinea to that in Guinea-Bissau?
Offer a very short reply. 0.48. What is the ratio of the Expenditure(as % of GDP) in 1995 in Guinea to that in Guyana?
Your response must be concise. 0.7. What is the ratio of the Expenditure(as % of GDP) of 1996 in Guinea to that in Guyana?
Your answer should be very brief. 0.63. What is the ratio of the Expenditure(as % of GDP) in 1997 in Guinea to that in Guyana?
Keep it short and to the point. 0.59. What is the ratio of the Expenditure(as % of GDP) in 1998 in Guinea to that in Guyana?
Provide a succinct answer. 0.64. What is the ratio of the Expenditure(as % of GDP) in 1995 in Guinea-Bissau to that in Guyana?
Keep it short and to the point. 1.27. What is the ratio of the Expenditure(as % of GDP) of 1996 in Guinea-Bissau to that in Guyana?
Provide a short and direct response. 1.41. What is the ratio of the Expenditure(as % of GDP) in 1997 in Guinea-Bissau to that in Guyana?
Ensure brevity in your answer.  1.31. What is the ratio of the Expenditure(as % of GDP) of 1998 in Guinea-Bissau to that in Guyana?
Make the answer very short. 1.34. What is the difference between the highest and the second highest Expenditure(as % of GDP) of 1995?
Offer a very short reply. 2.72. What is the difference between the highest and the second highest Expenditure(as % of GDP) in 1996?
Ensure brevity in your answer.  2.63. What is the difference between the highest and the second highest Expenditure(as % of GDP) of 1997?
Give a very brief answer. 2.2. What is the difference between the highest and the second highest Expenditure(as % of GDP) in 1998?
Provide a short and direct response. 2.02. What is the difference between the highest and the lowest Expenditure(as % of GDP) in 1995?
Make the answer very short. 6.09. What is the difference between the highest and the lowest Expenditure(as % of GDP) of 1996?
Provide a short and direct response. 6.45. What is the difference between the highest and the lowest Expenditure(as % of GDP) in 1997?
Offer a very short reply. 6.4. What is the difference between the highest and the lowest Expenditure(as % of GDP) in 1998?
Provide a succinct answer. 5.98. 